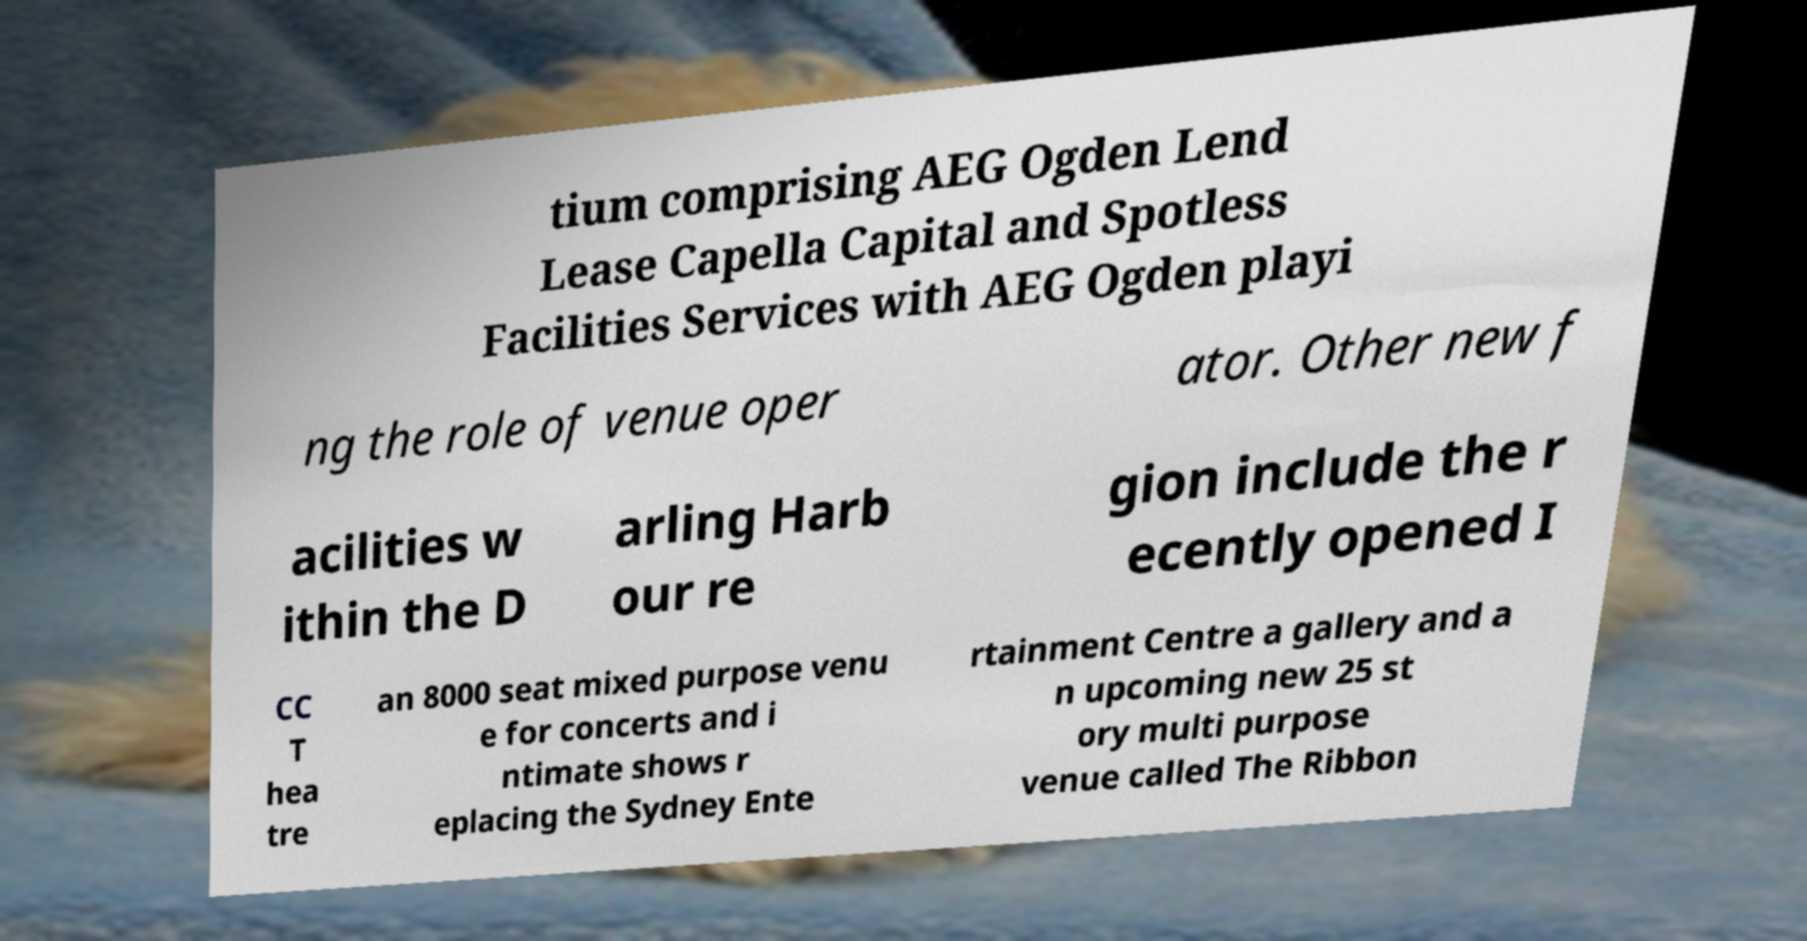Please read and relay the text visible in this image. What does it say? tium comprising AEG Ogden Lend Lease Capella Capital and Spotless Facilities Services with AEG Ogden playi ng the role of venue oper ator. Other new f acilities w ithin the D arling Harb our re gion include the r ecently opened I CC T hea tre an 8000 seat mixed purpose venu e for concerts and i ntimate shows r eplacing the Sydney Ente rtainment Centre a gallery and a n upcoming new 25 st ory multi purpose venue called The Ribbon 